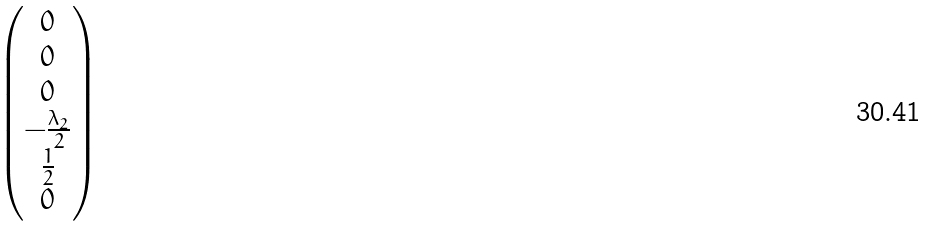Convert formula to latex. <formula><loc_0><loc_0><loc_500><loc_500>\begin{pmatrix} 0 \\ 0 \\ 0 \\ - \frac { \lambda _ { 2 } } { 2 } \\ \frac { 1 } { 2 } \\ 0 \end{pmatrix}</formula> 